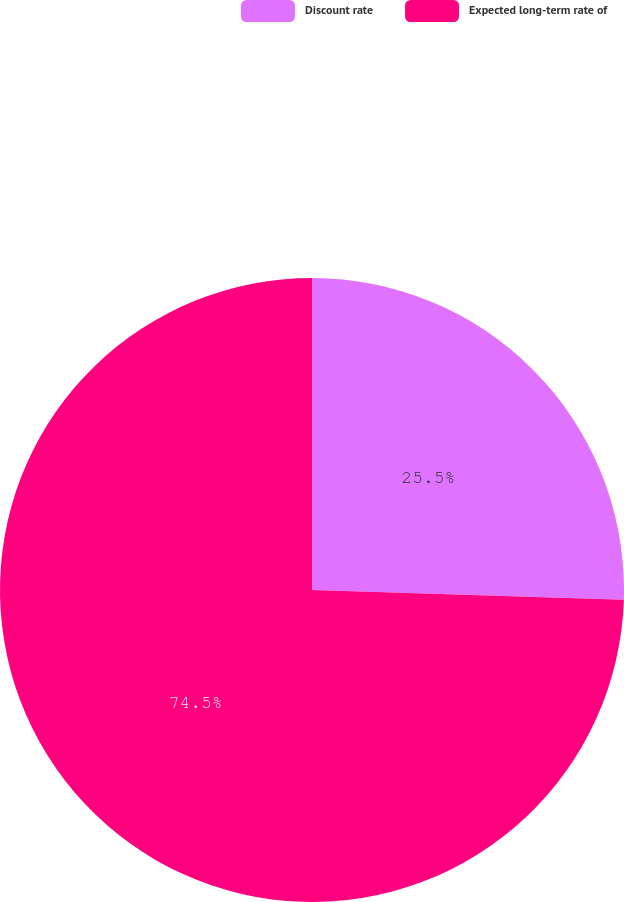Convert chart. <chart><loc_0><loc_0><loc_500><loc_500><pie_chart><fcel>Discount rate<fcel>Expected long-term rate of<nl><fcel>25.5%<fcel>74.5%<nl></chart> 